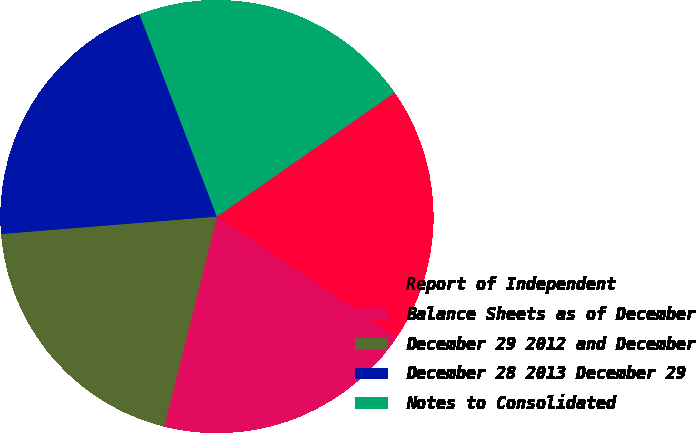Convert chart to OTSL. <chart><loc_0><loc_0><loc_500><loc_500><pie_chart><fcel>Report of Independent<fcel>Balance Sheets as of December<fcel>December 29 2012 and December<fcel>December 28 2013 December 29<fcel>Notes to Consolidated<nl><fcel>19.14%<fcel>19.47%<fcel>19.8%<fcel>20.46%<fcel>21.12%<nl></chart> 